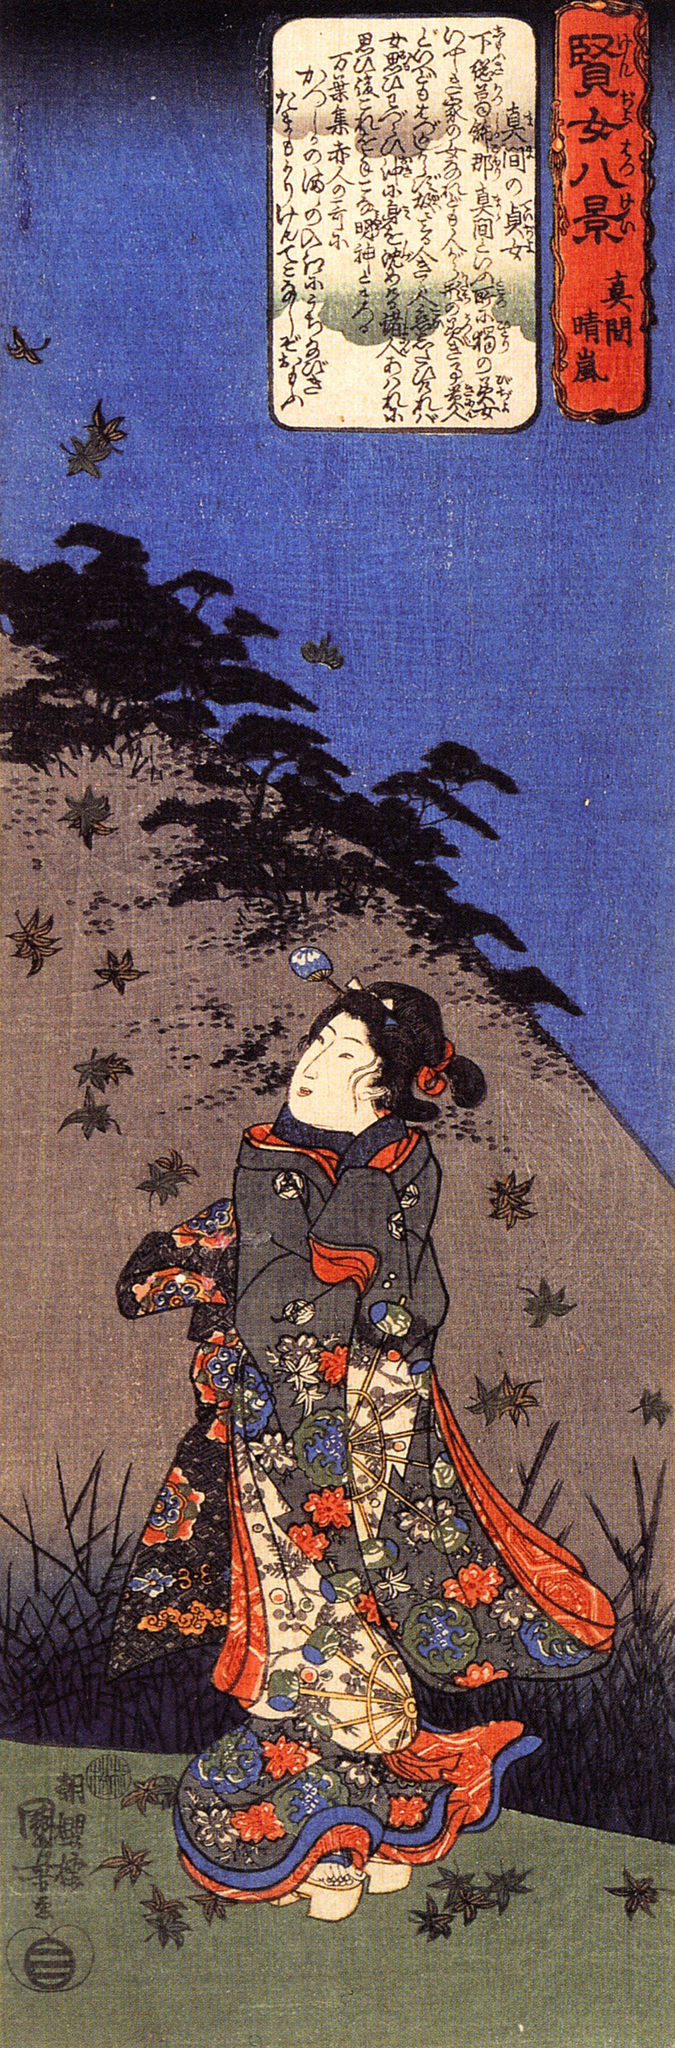Create a short poetic description based on the image. In twilight’s tender embrace,
A lady clad in hues' grace,
Gazes at the heights above,
Where birds serenade with love.
Mountains whisper ancient tales,
Of dreams, of peace, where silence prevails,
In her kimono, colors intertwine,
Nature and beauty in a delicate line. 